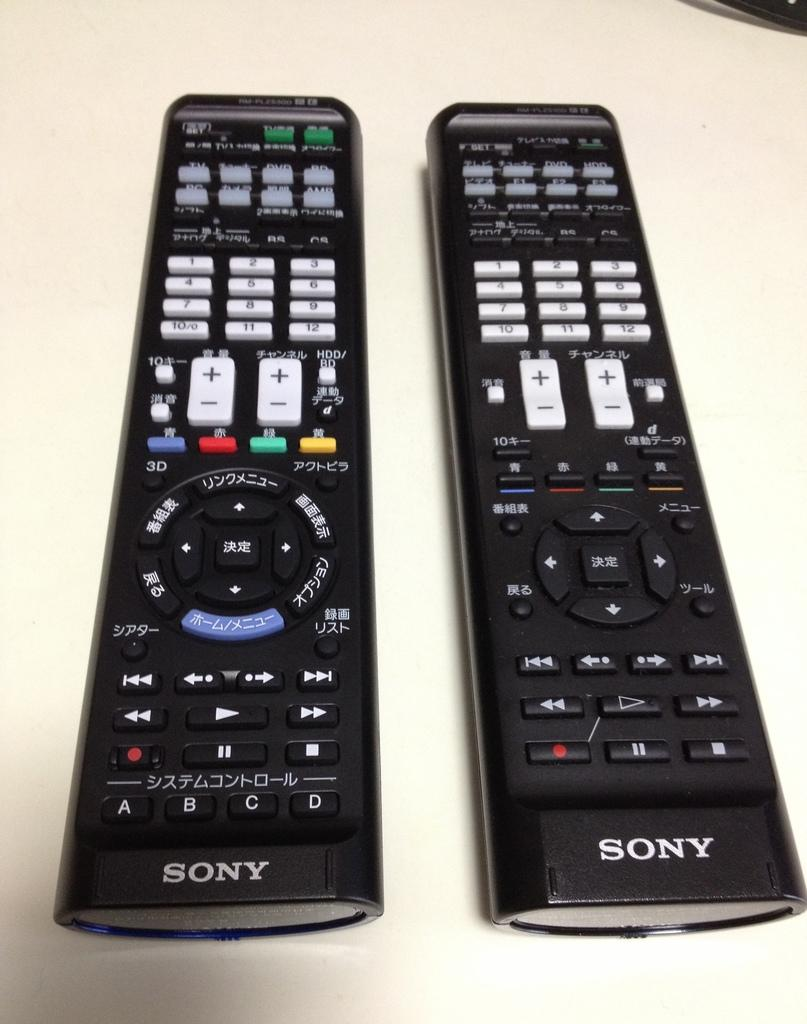<image>
Describe the image concisely. Two black Sony remotes sit side by side. 